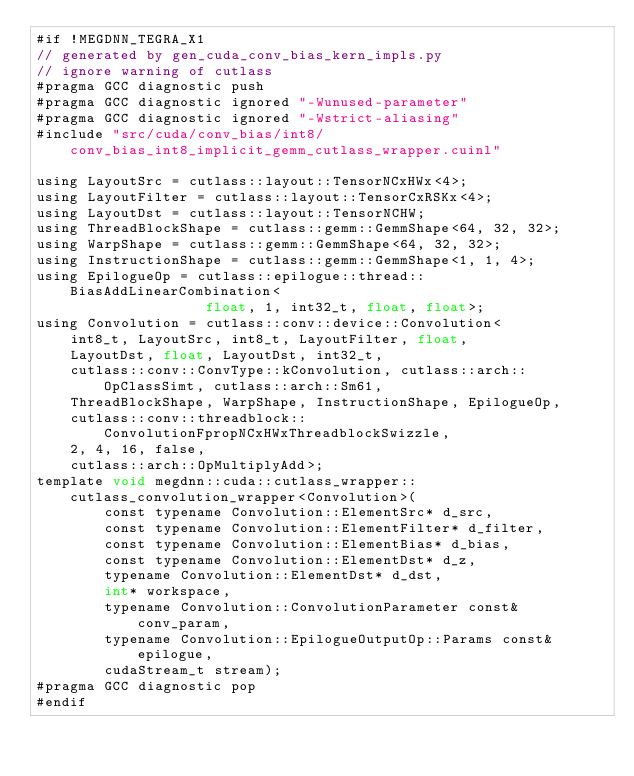Convert code to text. <code><loc_0><loc_0><loc_500><loc_500><_Cuda_>#if !MEGDNN_TEGRA_X1
// generated by gen_cuda_conv_bias_kern_impls.py
// ignore warning of cutlass
#pragma GCC diagnostic push
#pragma GCC diagnostic ignored "-Wunused-parameter"
#pragma GCC diagnostic ignored "-Wstrict-aliasing"
#include "src/cuda/conv_bias/int8/conv_bias_int8_implicit_gemm_cutlass_wrapper.cuinl"

using LayoutSrc = cutlass::layout::TensorNCxHWx<4>;
using LayoutFilter = cutlass::layout::TensorCxRSKx<4>;
using LayoutDst = cutlass::layout::TensorNCHW;
using ThreadBlockShape = cutlass::gemm::GemmShape<64, 32, 32>;
using WarpShape = cutlass::gemm::GemmShape<64, 32, 32>;
using InstructionShape = cutlass::gemm::GemmShape<1, 1, 4>;
using EpilogueOp = cutlass::epilogue::thread::BiasAddLinearCombination<
                    float, 1, int32_t, float, float>;
using Convolution = cutlass::conv::device::Convolution<
    int8_t, LayoutSrc, int8_t, LayoutFilter, float, 
    LayoutDst, float, LayoutDst, int32_t, 
    cutlass::conv::ConvType::kConvolution, cutlass::arch::OpClassSimt, cutlass::arch::Sm61, 
    ThreadBlockShape, WarpShape, InstructionShape, EpilogueOp, 
    cutlass::conv::threadblock::ConvolutionFpropNCxHWxThreadblockSwizzle, 
    2, 4, 16, false, 
    cutlass::arch::OpMultiplyAdd>;
template void megdnn::cuda::cutlass_wrapper::cutlass_convolution_wrapper<Convolution>(
        const typename Convolution::ElementSrc* d_src, 
        const typename Convolution::ElementFilter* d_filter, 
        const typename Convolution::ElementBias* d_bias, 
        const typename Convolution::ElementDst* d_z, 
        typename Convolution::ElementDst* d_dst, 
        int* workspace, 
        typename Convolution::ConvolutionParameter const& conv_param, 
        typename Convolution::EpilogueOutputOp::Params const& epilogue, 
        cudaStream_t stream);
#pragma GCC diagnostic pop
#endif
</code> 